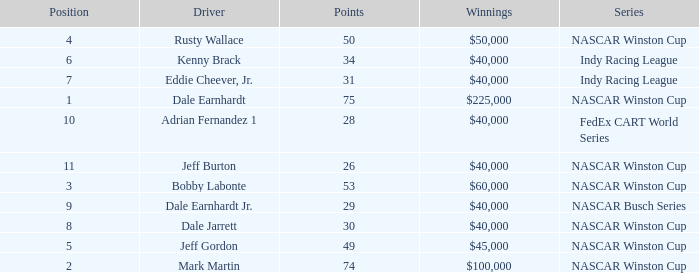In what position was the driver who won $60,000? 3.0. Write the full table. {'header': ['Position', 'Driver', 'Points', 'Winnings', 'Series'], 'rows': [['4', 'Rusty Wallace', '50', '$50,000', 'NASCAR Winston Cup'], ['6', 'Kenny Brack', '34', '$40,000', 'Indy Racing League'], ['7', 'Eddie Cheever, Jr.', '31', '$40,000', 'Indy Racing League'], ['1', 'Dale Earnhardt', '75', '$225,000', 'NASCAR Winston Cup'], ['10', 'Adrian Fernandez 1', '28', '$40,000', 'FedEx CART World Series'], ['11', 'Jeff Burton', '26', '$40,000', 'NASCAR Winston Cup'], ['3', 'Bobby Labonte', '53', '$60,000', 'NASCAR Winston Cup'], ['9', 'Dale Earnhardt Jr.', '29', '$40,000', 'NASCAR Busch Series'], ['8', 'Dale Jarrett', '30', '$40,000', 'NASCAR Winston Cup'], ['5', 'Jeff Gordon', '49', '$45,000', 'NASCAR Winston Cup'], ['2', 'Mark Martin', '74', '$100,000', 'NASCAR Winston Cup']]} 